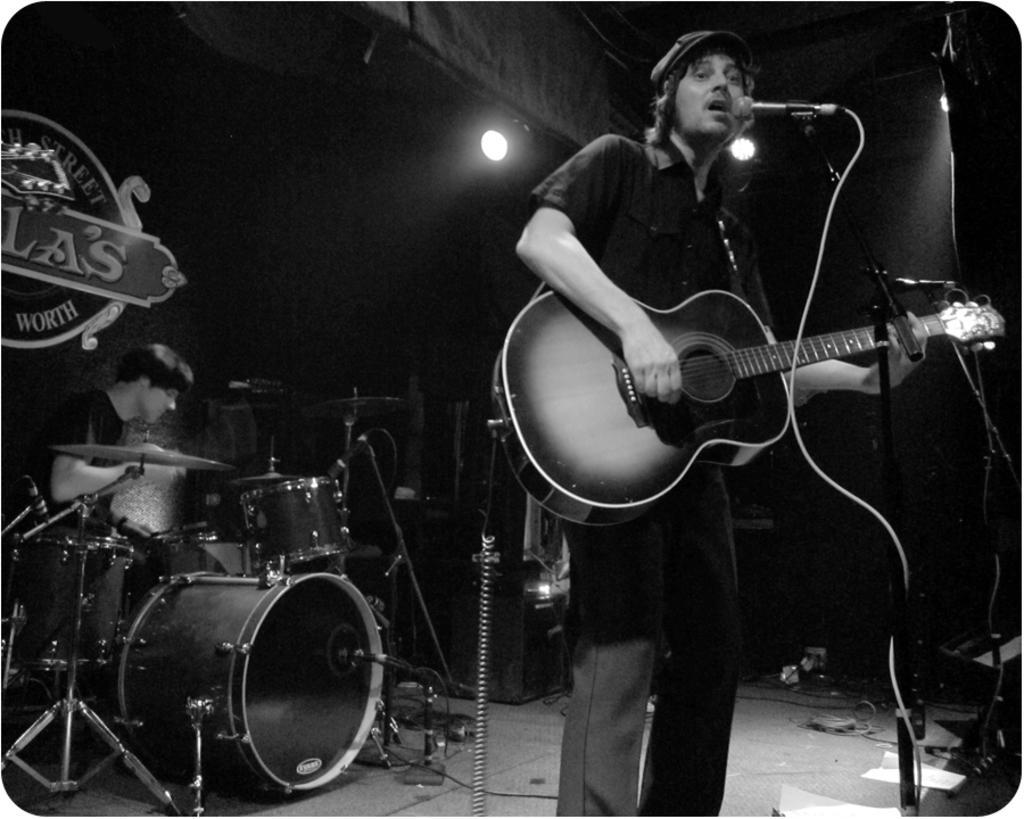Can you describe this image briefly? In this image, In the right side there is a man standing and holding a music instrument which is in black color he is singing in the microphone, In the left side there are some music instruments there is a person sitting and playing the music instruments, In the top there is a white color light in the middle. 